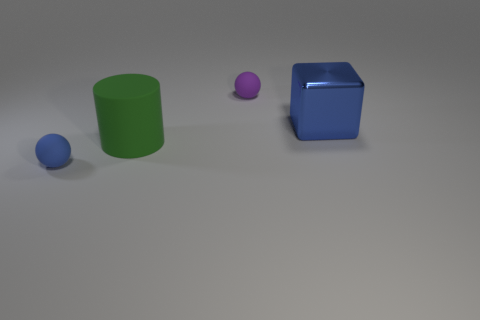What textures are visible on the surfaces of the objects? The surfaces of the objects appear smooth and matte, without any distinct texture or pattern. 